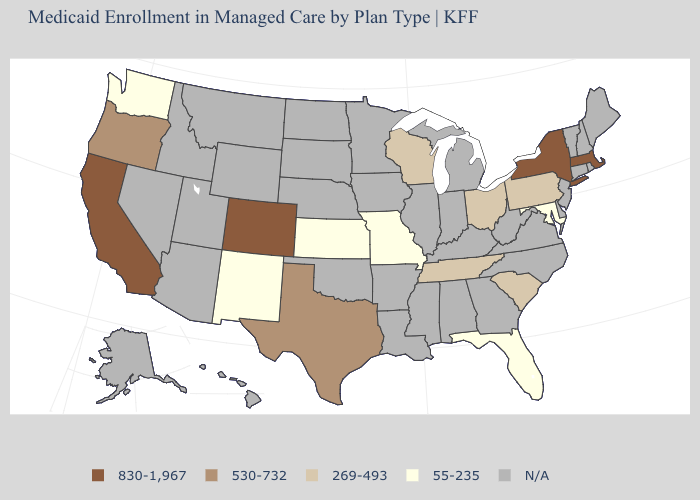Which states hav the highest value in the West?
Short answer required. California, Colorado. Name the states that have a value in the range 269-493?
Keep it brief. Ohio, Pennsylvania, South Carolina, Tennessee, Wisconsin. Which states have the highest value in the USA?
Be succinct. California, Colorado, Massachusetts, New York. Name the states that have a value in the range 269-493?
Be succinct. Ohio, Pennsylvania, South Carolina, Tennessee, Wisconsin. Name the states that have a value in the range 830-1,967?
Quick response, please. California, Colorado, Massachusetts, New York. What is the value of Georgia?
Write a very short answer. N/A. Name the states that have a value in the range 530-732?
Keep it brief. Oregon, Texas. What is the lowest value in the USA?
Short answer required. 55-235. What is the value of California?
Concise answer only. 830-1,967. Which states have the lowest value in the South?
Short answer required. Florida, Maryland. Name the states that have a value in the range 269-493?
Keep it brief. Ohio, Pennsylvania, South Carolina, Tennessee, Wisconsin. What is the value of Arkansas?
Answer briefly. N/A. Among the states that border Iowa , which have the highest value?
Short answer required. Wisconsin. Name the states that have a value in the range 530-732?
Give a very brief answer. Oregon, Texas. 